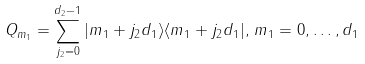Convert formula to latex. <formula><loc_0><loc_0><loc_500><loc_500>Q _ { m _ { 1 } } = \sum _ { j _ { 2 } = 0 } ^ { d _ { 2 } - 1 } | m _ { 1 } + j _ { 2 } d _ { 1 } \rangle \langle m _ { 1 } + j _ { 2 } d _ { 1 } | , \, m _ { 1 } = 0 , \dots , d _ { 1 }</formula> 